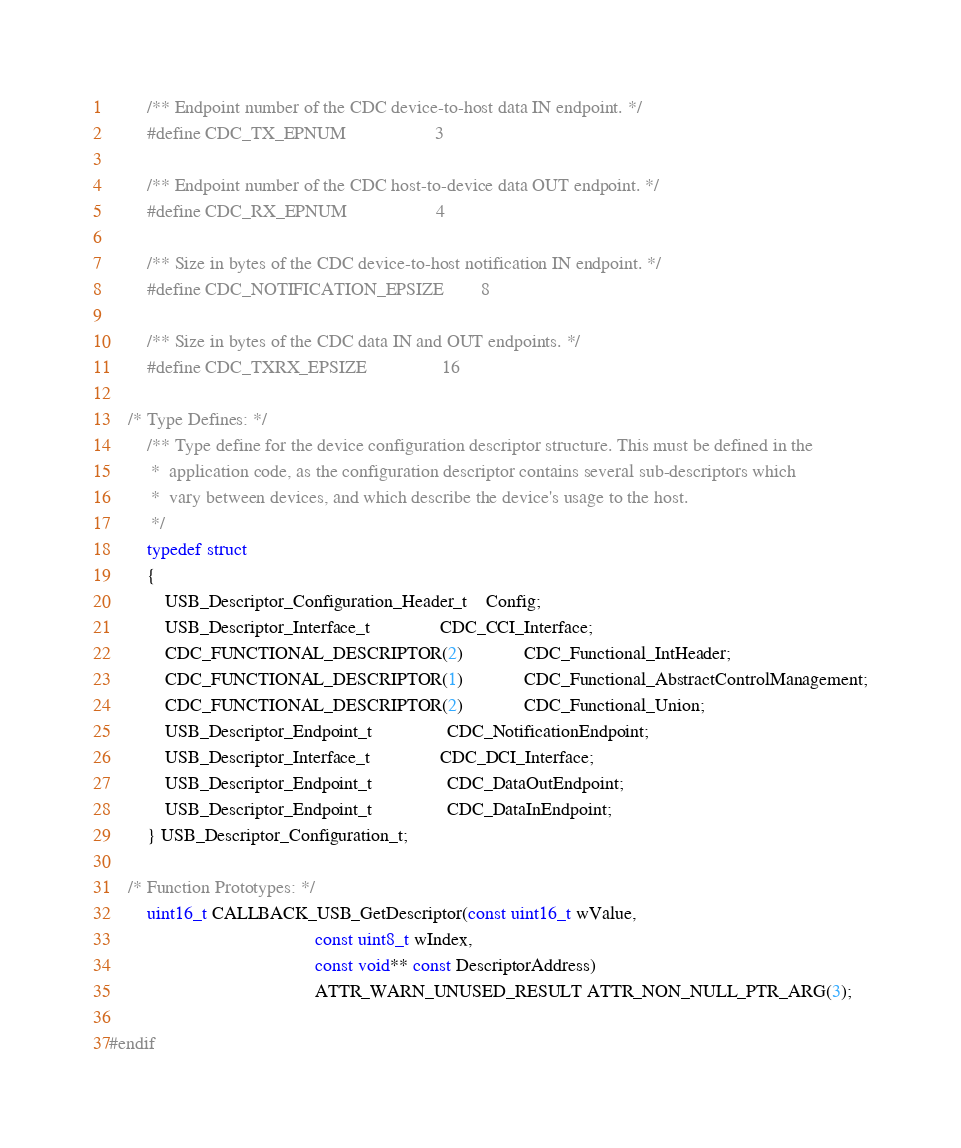Convert code to text. <code><loc_0><loc_0><loc_500><loc_500><_C_>
		/** Endpoint number of the CDC device-to-host data IN endpoint. */
		#define CDC_TX_EPNUM                   3

		/** Endpoint number of the CDC host-to-device data OUT endpoint. */
		#define CDC_RX_EPNUM                   4

		/** Size in bytes of the CDC device-to-host notification IN endpoint. */
		#define CDC_NOTIFICATION_EPSIZE        8

		/** Size in bytes of the CDC data IN and OUT endpoints. */
		#define CDC_TXRX_EPSIZE                16

	/* Type Defines: */
		/** Type define for the device configuration descriptor structure. This must be defined in the
		 *  application code, as the configuration descriptor contains several sub-descriptors which
		 *  vary between devices, and which describe the device's usage to the host.
		 */
		typedef struct
		{
			USB_Descriptor_Configuration_Header_t    Config;
			USB_Descriptor_Interface_t               CDC_CCI_Interface;
			CDC_FUNCTIONAL_DESCRIPTOR(2)             CDC_Functional_IntHeader;
			CDC_FUNCTIONAL_DESCRIPTOR(1)             CDC_Functional_AbstractControlManagement;
			CDC_FUNCTIONAL_DESCRIPTOR(2)             CDC_Functional_Union;
			USB_Descriptor_Endpoint_t                CDC_NotificationEndpoint;
			USB_Descriptor_Interface_t               CDC_DCI_Interface;
			USB_Descriptor_Endpoint_t                CDC_DataOutEndpoint;
			USB_Descriptor_Endpoint_t                CDC_DataInEndpoint;
		} USB_Descriptor_Configuration_t;

	/* Function Prototypes: */
		uint16_t CALLBACK_USB_GetDescriptor(const uint16_t wValue,
		                                    const uint8_t wIndex,
		                                    const void** const DescriptorAddress)
		                                    ATTR_WARN_UNUSED_RESULT ATTR_NON_NULL_PTR_ARG(3);

#endif
</code> 